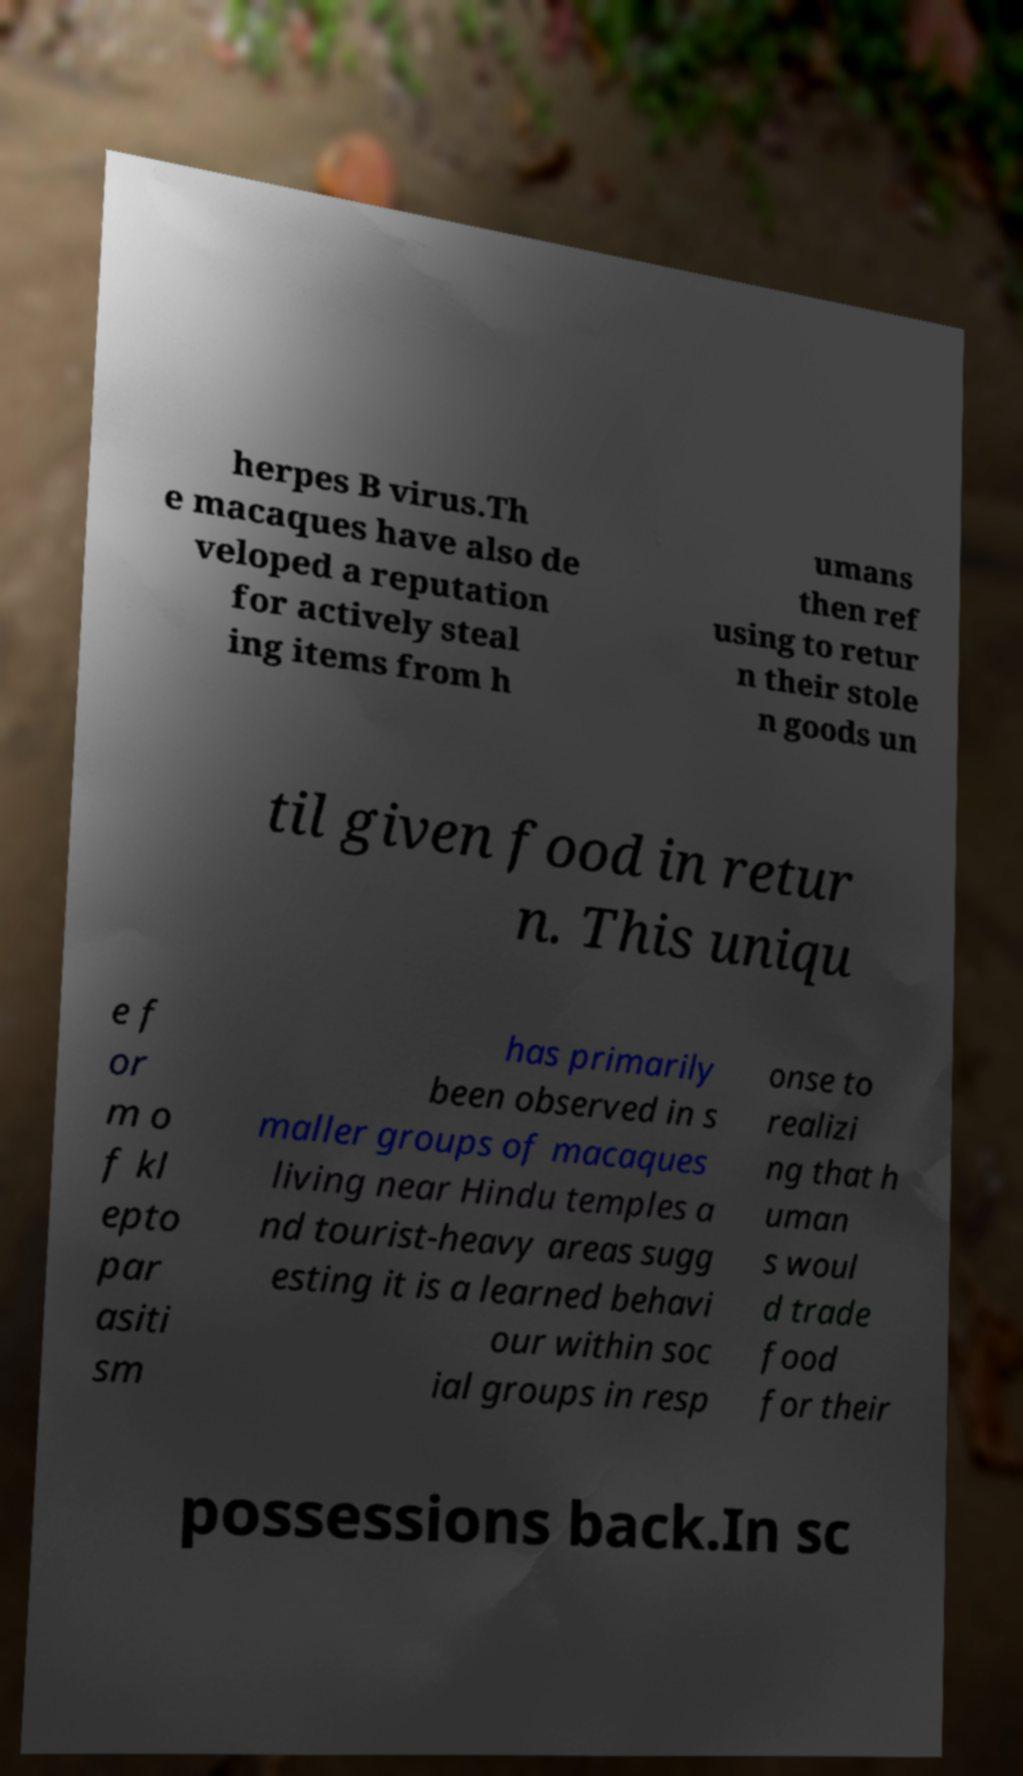Can you read and provide the text displayed in the image?This photo seems to have some interesting text. Can you extract and type it out for me? herpes B virus.Th e macaques have also de veloped a reputation for actively steal ing items from h umans then ref using to retur n their stole n goods un til given food in retur n. This uniqu e f or m o f kl epto par asiti sm has primarily been observed in s maller groups of macaques living near Hindu temples a nd tourist-heavy areas sugg esting it is a learned behavi our within soc ial groups in resp onse to realizi ng that h uman s woul d trade food for their possessions back.In sc 